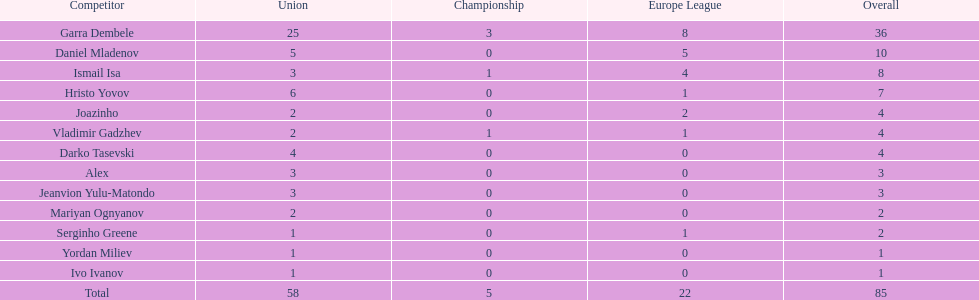Which is the only player from germany? Jeanvion Yulu-Matondo. 